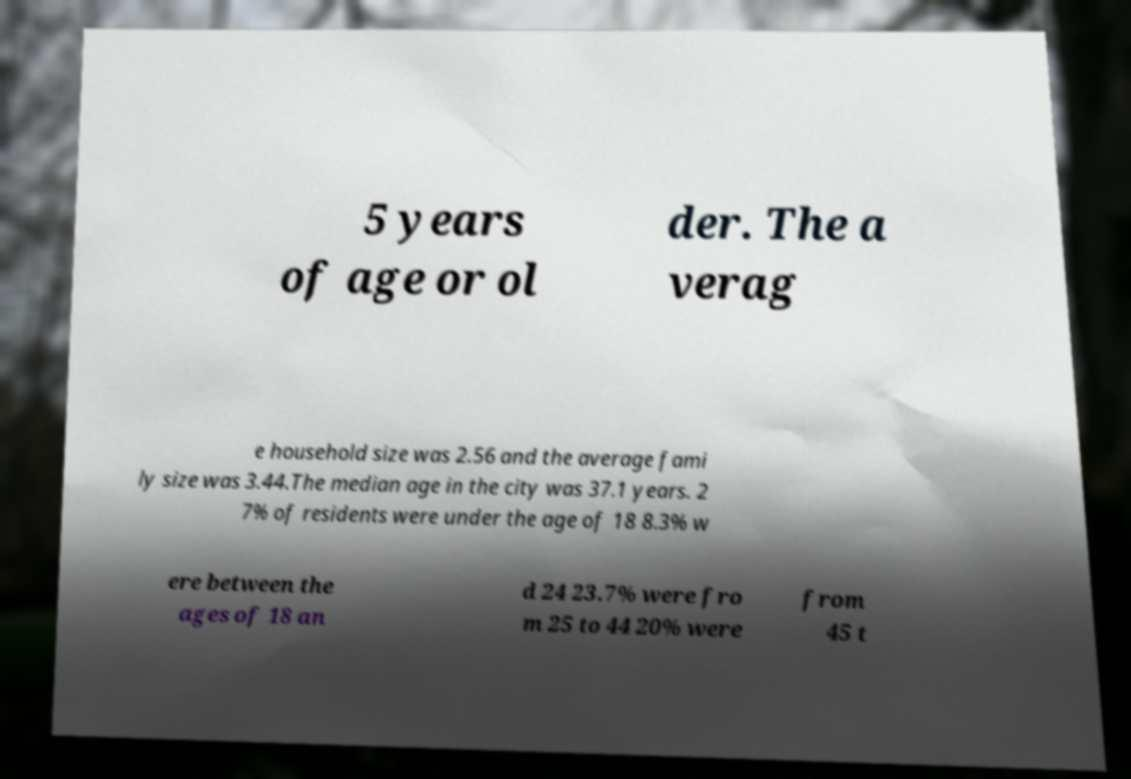What messages or text are displayed in this image? I need them in a readable, typed format. 5 years of age or ol der. The a verag e household size was 2.56 and the average fami ly size was 3.44.The median age in the city was 37.1 years. 2 7% of residents were under the age of 18 8.3% w ere between the ages of 18 an d 24 23.7% were fro m 25 to 44 20% were from 45 t 